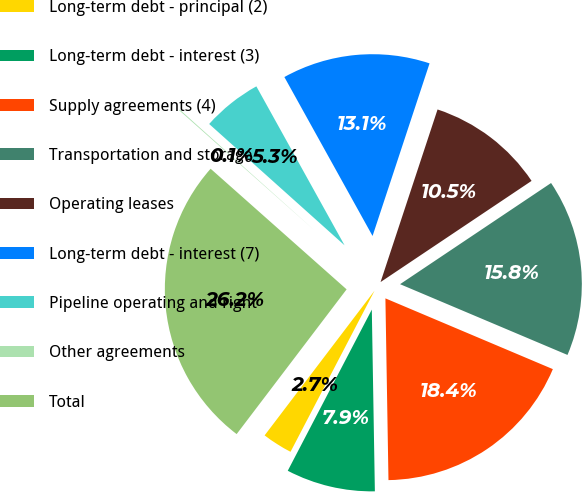Convert chart to OTSL. <chart><loc_0><loc_0><loc_500><loc_500><pie_chart><fcel>Long-term debt - principal (2)<fcel>Long-term debt - interest (3)<fcel>Supply agreements (4)<fcel>Transportation and storage<fcel>Operating leases<fcel>Long-term debt - interest (7)<fcel>Pipeline operating and right<fcel>Other agreements<fcel>Total<nl><fcel>2.69%<fcel>7.92%<fcel>18.37%<fcel>15.76%<fcel>10.53%<fcel>13.14%<fcel>5.31%<fcel>0.08%<fcel>26.21%<nl></chart> 